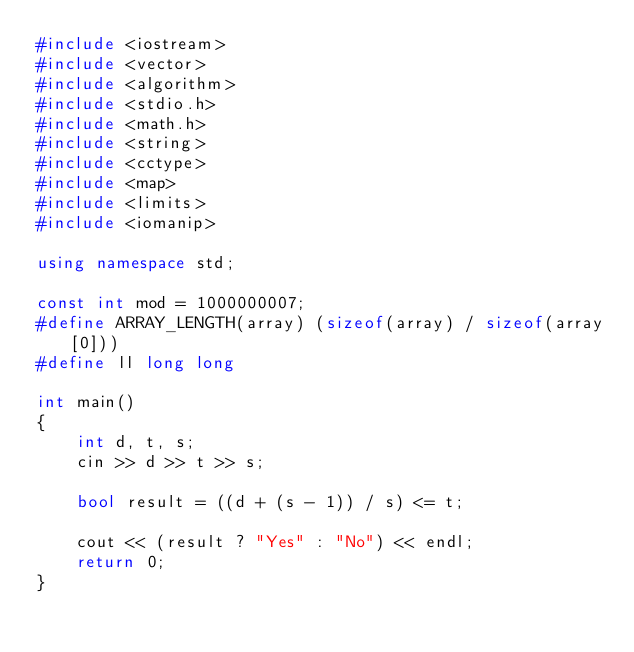<code> <loc_0><loc_0><loc_500><loc_500><_C++_>#include <iostream>
#include <vector>
#include <algorithm>
#include <stdio.h>
#include <math.h>
#include <string>
#include <cctype>
#include <map>
#include <limits>
#include <iomanip>

using namespace std;

const int mod = 1000000007;
#define ARRAY_LENGTH(array) (sizeof(array) / sizeof(array[0]))
#define ll long long

int main()
{
	int d, t, s;
	cin >> d >> t >> s;

	bool result = ((d + (s - 1)) / s) <= t;

	cout << (result ? "Yes" : "No") << endl;
	return 0;
}</code> 